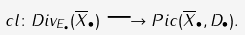<formula> <loc_0><loc_0><loc_500><loc_500>c l \colon D i v _ { E _ { \bullet } } ( \overline { X } _ { \bullet } ) \longrightarrow P i c ( \overline { X } _ { \bullet } , D _ { \bullet } ) .</formula> 